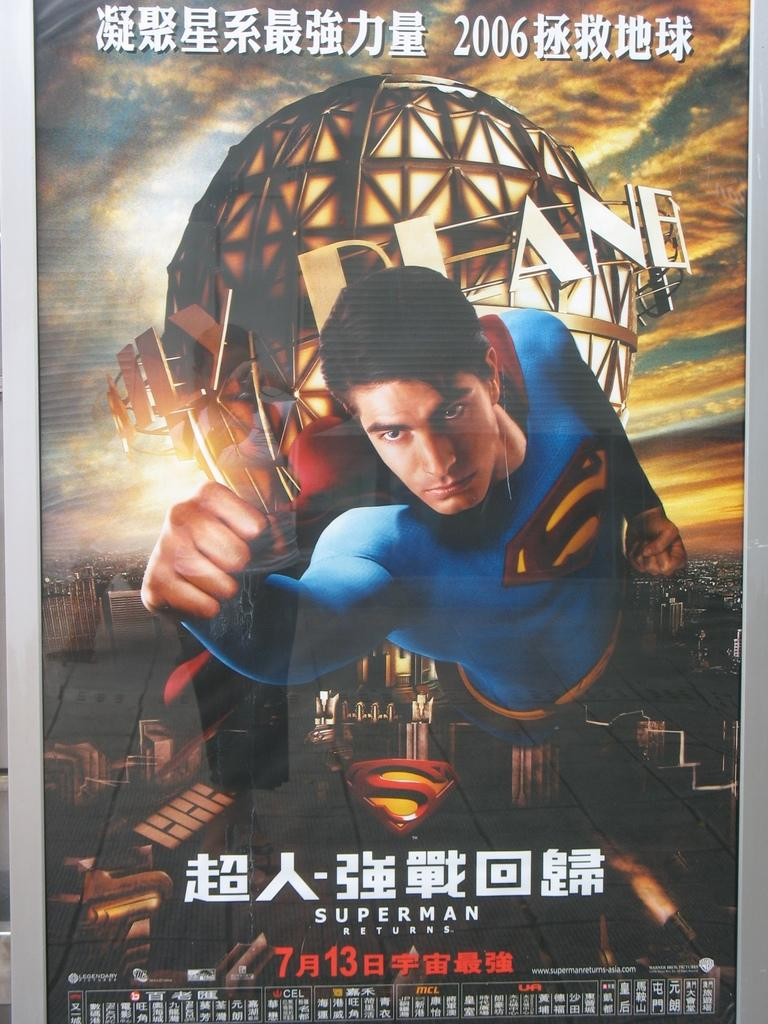<image>
Give a short and clear explanation of the subsequent image. A foreign language poster for the 2006 movie Superman Returns. 